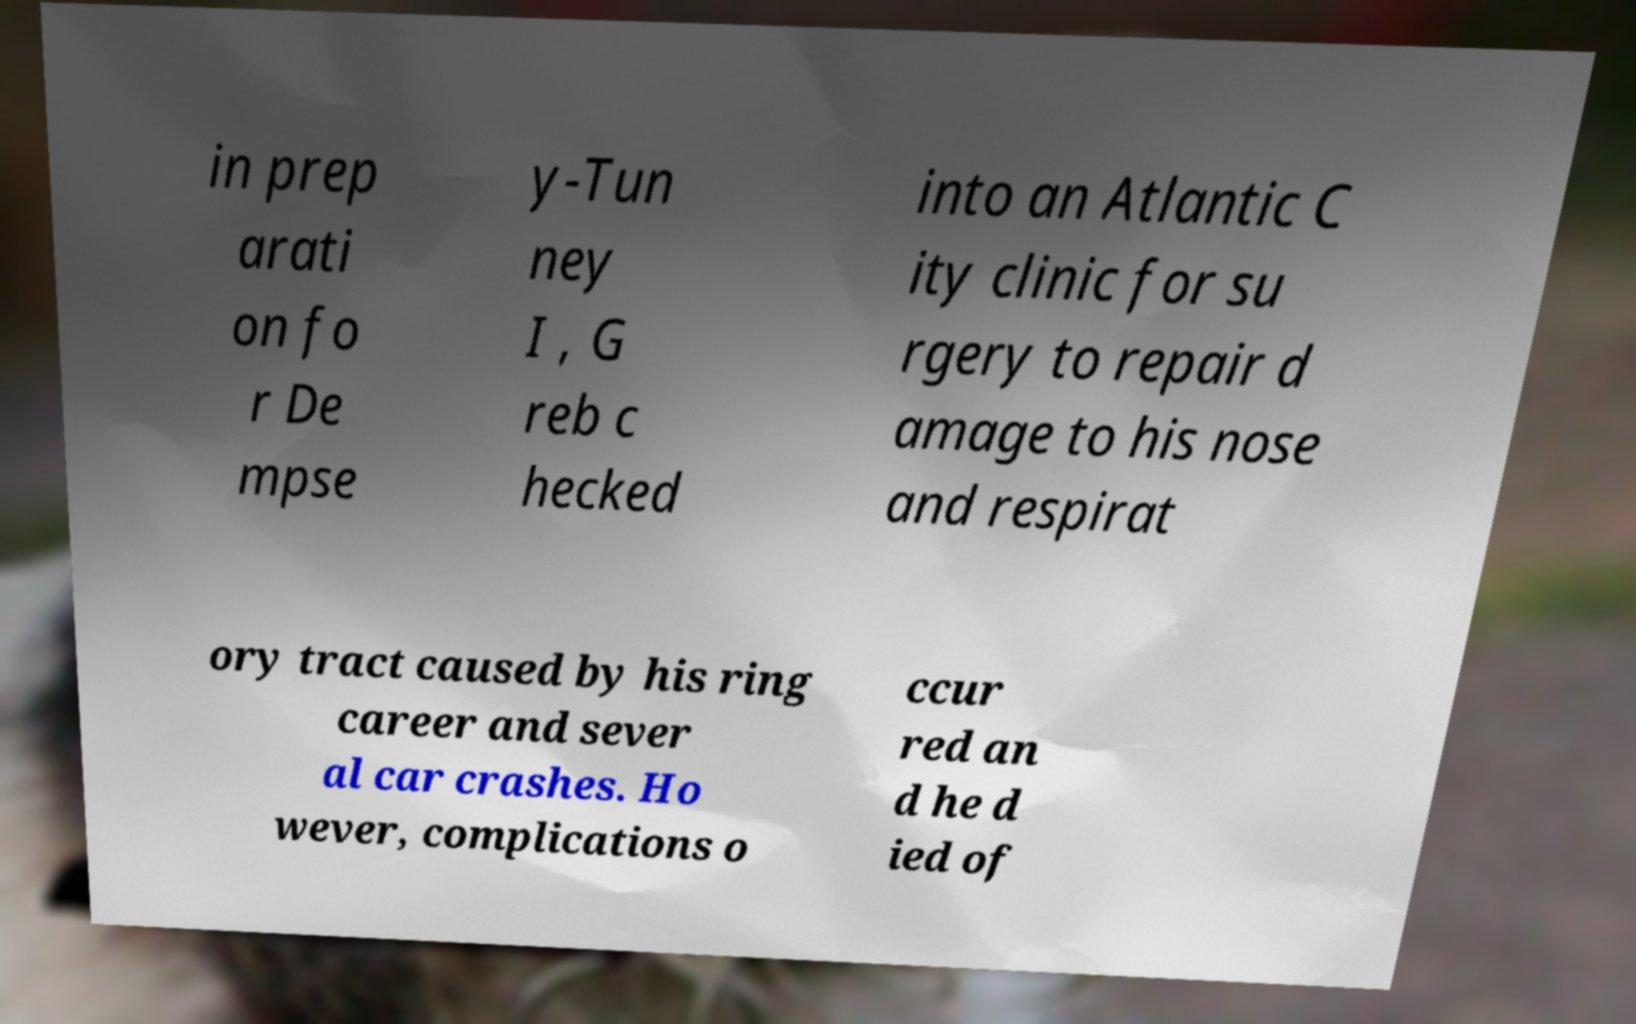Please identify and transcribe the text found in this image. in prep arati on fo r De mpse y-Tun ney I , G reb c hecked into an Atlantic C ity clinic for su rgery to repair d amage to his nose and respirat ory tract caused by his ring career and sever al car crashes. Ho wever, complications o ccur red an d he d ied of 